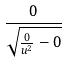Convert formula to latex. <formula><loc_0><loc_0><loc_500><loc_500>\frac { 0 } { \sqrt { \frac { 0 } { u ^ { 2 } } - 0 } }</formula> 